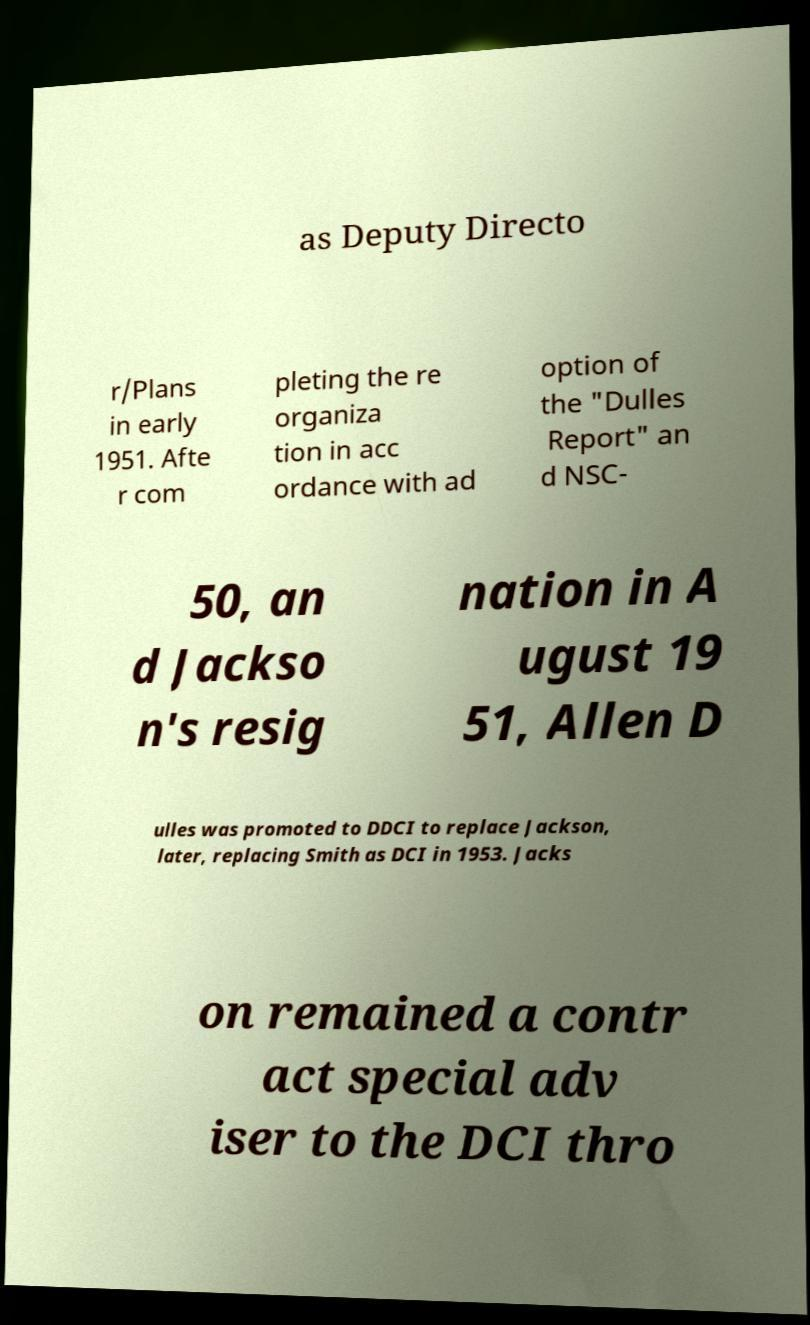Please read and relay the text visible in this image. What does it say? as Deputy Directo r/Plans in early 1951. Afte r com pleting the re organiza tion in acc ordance with ad option of the "Dulles Report" an d NSC- 50, an d Jackso n's resig nation in A ugust 19 51, Allen D ulles was promoted to DDCI to replace Jackson, later, replacing Smith as DCI in 1953. Jacks on remained a contr act special adv iser to the DCI thro 